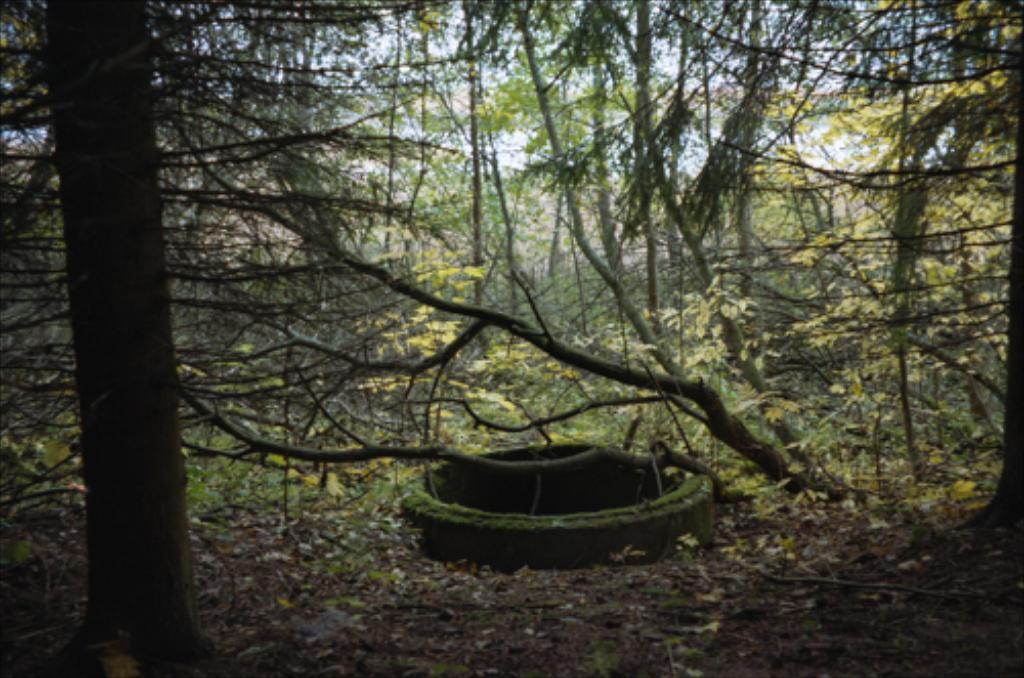What is located on the left side of the image? There is a tree on the left side of the image. What can be seen in the background of the image? There are plants, trees, and the sky visible in the background of the image. What type of government can be seen ruling the island in the image? There is no island or government present in the image; it features a tree and background elements. 